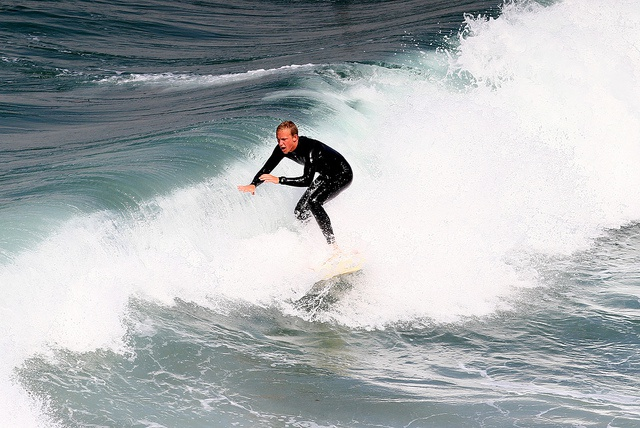Describe the objects in this image and their specific colors. I can see people in darkblue, black, lightgray, gray, and darkgray tones, surfboard in darkblue, darkgray, lightgray, and gray tones, and surfboard in darkblue, ivory, tan, and darkgray tones in this image. 